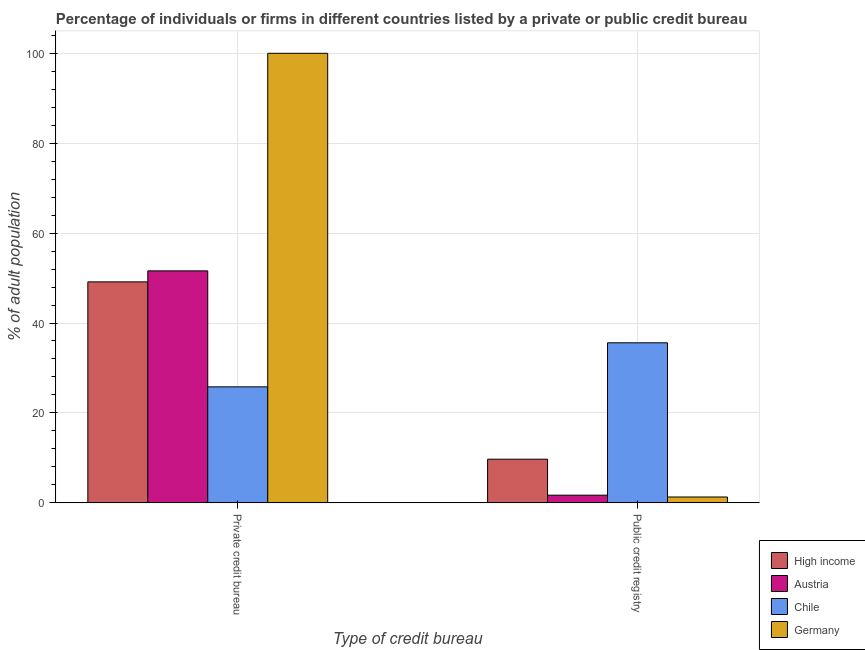How many different coloured bars are there?
Keep it short and to the point. 4. How many bars are there on the 1st tick from the left?
Your answer should be very brief. 4. What is the label of the 2nd group of bars from the left?
Provide a short and direct response. Public credit registry. Across all countries, what is the maximum percentage of firms listed by public credit bureau?
Offer a terse response. 35.6. Across all countries, what is the minimum percentage of firms listed by public credit bureau?
Make the answer very short. 1.3. In which country was the percentage of firms listed by public credit bureau maximum?
Keep it short and to the point. Chile. In which country was the percentage of firms listed by private credit bureau minimum?
Keep it short and to the point. Chile. What is the total percentage of firms listed by public credit bureau in the graph?
Give a very brief answer. 48.31. What is the difference between the percentage of firms listed by public credit bureau in High income and that in Chile?
Offer a terse response. -25.89. What is the difference between the percentage of firms listed by public credit bureau in Austria and the percentage of firms listed by private credit bureau in Chile?
Keep it short and to the point. -24.1. What is the average percentage of firms listed by public credit bureau per country?
Your answer should be compact. 12.08. What is the difference between the percentage of firms listed by public credit bureau and percentage of firms listed by private credit bureau in Chile?
Offer a very short reply. 9.8. What is the ratio of the percentage of firms listed by public credit bureau in Germany to that in Chile?
Your answer should be very brief. 0.04. In how many countries, is the percentage of firms listed by private credit bureau greater than the average percentage of firms listed by private credit bureau taken over all countries?
Make the answer very short. 1. What does the 1st bar from the left in Public credit registry represents?
Keep it short and to the point. High income. What does the 4th bar from the right in Public credit registry represents?
Make the answer very short. High income. How many bars are there?
Offer a terse response. 8. Are all the bars in the graph horizontal?
Your response must be concise. No. Are the values on the major ticks of Y-axis written in scientific E-notation?
Provide a short and direct response. No. Does the graph contain any zero values?
Provide a short and direct response. No. Where does the legend appear in the graph?
Your answer should be very brief. Bottom right. How many legend labels are there?
Your answer should be compact. 4. How are the legend labels stacked?
Give a very brief answer. Vertical. What is the title of the graph?
Keep it short and to the point. Percentage of individuals or firms in different countries listed by a private or public credit bureau. What is the label or title of the X-axis?
Keep it short and to the point. Type of credit bureau. What is the label or title of the Y-axis?
Offer a terse response. % of adult population. What is the % of adult population in High income in Private credit bureau?
Your answer should be very brief. 49.15. What is the % of adult population in Austria in Private credit bureau?
Give a very brief answer. 51.6. What is the % of adult population in Chile in Private credit bureau?
Provide a succinct answer. 25.8. What is the % of adult population in Germany in Private credit bureau?
Provide a succinct answer. 100. What is the % of adult population of High income in Public credit registry?
Make the answer very short. 9.71. What is the % of adult population in Austria in Public credit registry?
Offer a very short reply. 1.7. What is the % of adult population of Chile in Public credit registry?
Make the answer very short. 35.6. What is the % of adult population in Germany in Public credit registry?
Give a very brief answer. 1.3. Across all Type of credit bureau, what is the maximum % of adult population in High income?
Make the answer very short. 49.15. Across all Type of credit bureau, what is the maximum % of adult population in Austria?
Offer a very short reply. 51.6. Across all Type of credit bureau, what is the maximum % of adult population in Chile?
Provide a succinct answer. 35.6. Across all Type of credit bureau, what is the maximum % of adult population in Germany?
Offer a terse response. 100. Across all Type of credit bureau, what is the minimum % of adult population in High income?
Provide a short and direct response. 9.71. Across all Type of credit bureau, what is the minimum % of adult population in Austria?
Provide a short and direct response. 1.7. Across all Type of credit bureau, what is the minimum % of adult population of Chile?
Ensure brevity in your answer.  25.8. What is the total % of adult population in High income in the graph?
Provide a succinct answer. 58.86. What is the total % of adult population of Austria in the graph?
Offer a very short reply. 53.3. What is the total % of adult population of Chile in the graph?
Keep it short and to the point. 61.4. What is the total % of adult population of Germany in the graph?
Give a very brief answer. 101.3. What is the difference between the % of adult population in High income in Private credit bureau and that in Public credit registry?
Make the answer very short. 39.45. What is the difference between the % of adult population in Austria in Private credit bureau and that in Public credit registry?
Keep it short and to the point. 49.9. What is the difference between the % of adult population of Chile in Private credit bureau and that in Public credit registry?
Provide a succinct answer. -9.8. What is the difference between the % of adult population of Germany in Private credit bureau and that in Public credit registry?
Ensure brevity in your answer.  98.7. What is the difference between the % of adult population in High income in Private credit bureau and the % of adult population in Austria in Public credit registry?
Make the answer very short. 47.45. What is the difference between the % of adult population of High income in Private credit bureau and the % of adult population of Chile in Public credit registry?
Make the answer very short. 13.55. What is the difference between the % of adult population of High income in Private credit bureau and the % of adult population of Germany in Public credit registry?
Offer a terse response. 47.85. What is the difference between the % of adult population in Austria in Private credit bureau and the % of adult population in Chile in Public credit registry?
Keep it short and to the point. 16. What is the difference between the % of adult population of Austria in Private credit bureau and the % of adult population of Germany in Public credit registry?
Your answer should be very brief. 50.3. What is the average % of adult population in High income per Type of credit bureau?
Ensure brevity in your answer.  29.43. What is the average % of adult population in Austria per Type of credit bureau?
Provide a short and direct response. 26.65. What is the average % of adult population of Chile per Type of credit bureau?
Keep it short and to the point. 30.7. What is the average % of adult population of Germany per Type of credit bureau?
Make the answer very short. 50.65. What is the difference between the % of adult population of High income and % of adult population of Austria in Private credit bureau?
Keep it short and to the point. -2.45. What is the difference between the % of adult population of High income and % of adult population of Chile in Private credit bureau?
Provide a short and direct response. 23.35. What is the difference between the % of adult population in High income and % of adult population in Germany in Private credit bureau?
Provide a short and direct response. -50.85. What is the difference between the % of adult population of Austria and % of adult population of Chile in Private credit bureau?
Your answer should be very brief. 25.8. What is the difference between the % of adult population in Austria and % of adult population in Germany in Private credit bureau?
Keep it short and to the point. -48.4. What is the difference between the % of adult population of Chile and % of adult population of Germany in Private credit bureau?
Keep it short and to the point. -74.2. What is the difference between the % of adult population in High income and % of adult population in Austria in Public credit registry?
Provide a succinct answer. 8.01. What is the difference between the % of adult population of High income and % of adult population of Chile in Public credit registry?
Your answer should be very brief. -25.89. What is the difference between the % of adult population in High income and % of adult population in Germany in Public credit registry?
Offer a terse response. 8.41. What is the difference between the % of adult population in Austria and % of adult population in Chile in Public credit registry?
Make the answer very short. -33.9. What is the difference between the % of adult population in Austria and % of adult population in Germany in Public credit registry?
Provide a short and direct response. 0.4. What is the difference between the % of adult population of Chile and % of adult population of Germany in Public credit registry?
Provide a succinct answer. 34.3. What is the ratio of the % of adult population of High income in Private credit bureau to that in Public credit registry?
Provide a short and direct response. 5.06. What is the ratio of the % of adult population in Austria in Private credit bureau to that in Public credit registry?
Give a very brief answer. 30.35. What is the ratio of the % of adult population in Chile in Private credit bureau to that in Public credit registry?
Provide a succinct answer. 0.72. What is the ratio of the % of adult population in Germany in Private credit bureau to that in Public credit registry?
Provide a succinct answer. 76.92. What is the difference between the highest and the second highest % of adult population of High income?
Your response must be concise. 39.45. What is the difference between the highest and the second highest % of adult population of Austria?
Your response must be concise. 49.9. What is the difference between the highest and the second highest % of adult population of Chile?
Your answer should be very brief. 9.8. What is the difference between the highest and the second highest % of adult population in Germany?
Ensure brevity in your answer.  98.7. What is the difference between the highest and the lowest % of adult population of High income?
Your answer should be compact. 39.45. What is the difference between the highest and the lowest % of adult population of Austria?
Offer a very short reply. 49.9. What is the difference between the highest and the lowest % of adult population in Germany?
Ensure brevity in your answer.  98.7. 